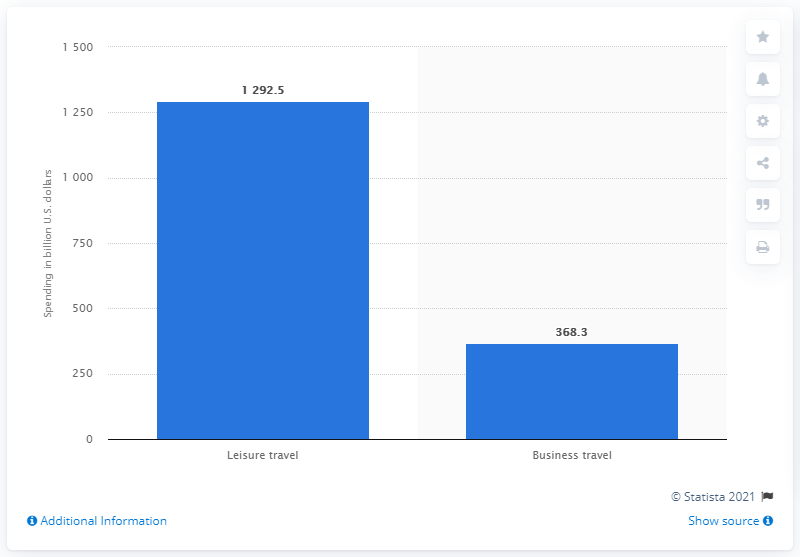List a handful of essential elements in this visual. In 2017, the United States spent 1,292.5 billion dollars on leisure travel. 